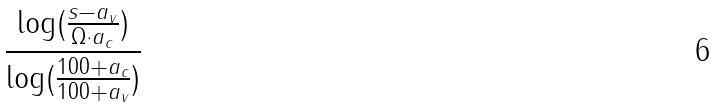<formula> <loc_0><loc_0><loc_500><loc_500>\frac { \log ( \frac { s - a _ { v } } { \Omega \cdot a _ { c } } ) } { \log ( \frac { 1 0 0 + a _ { c } } { 1 0 0 + a _ { v } } ) }</formula> 